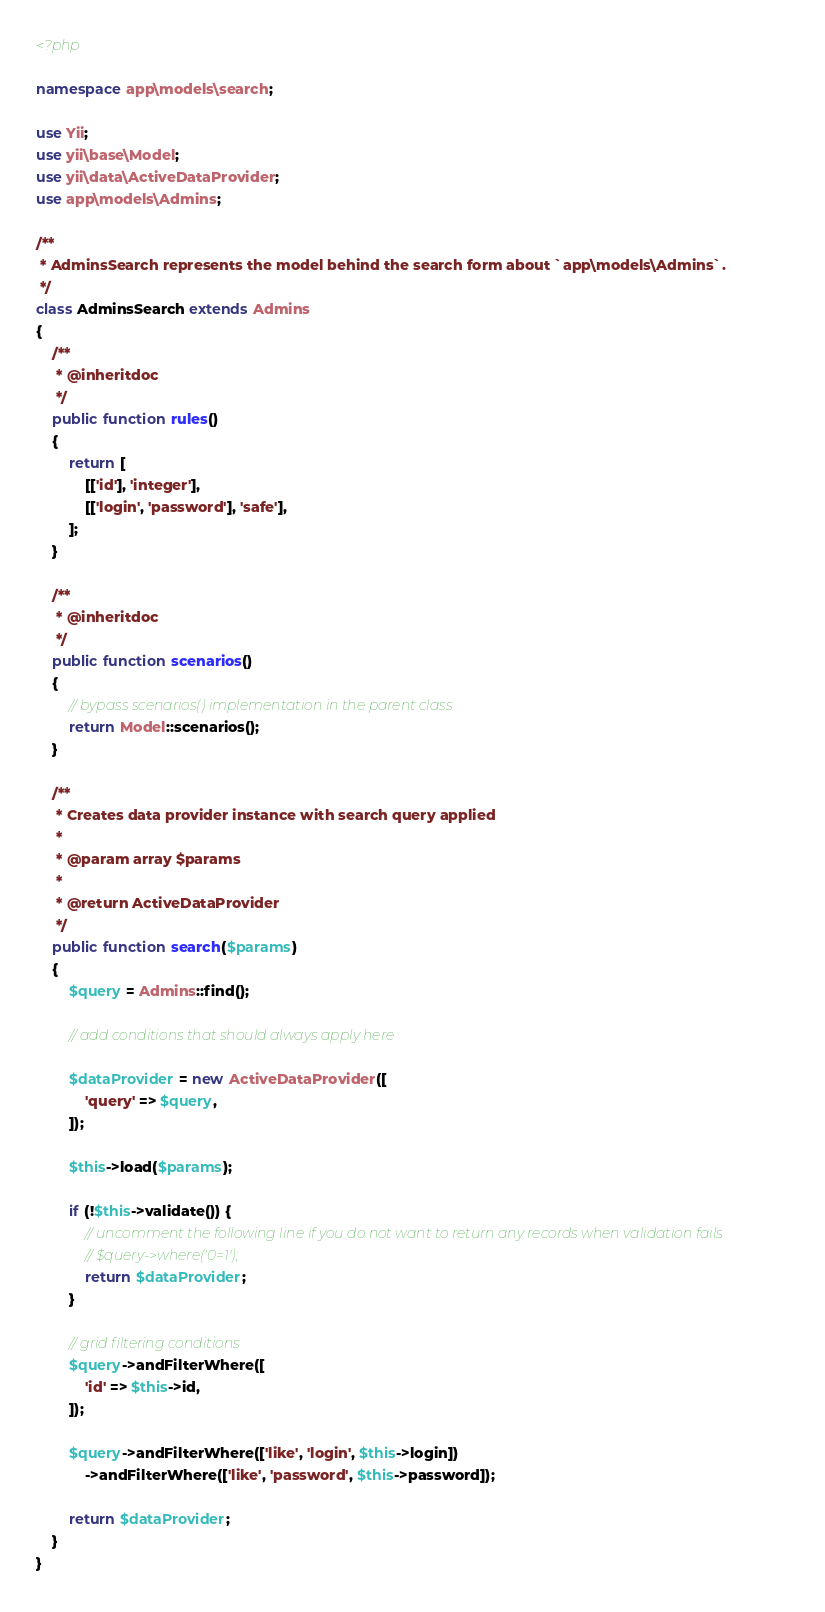<code> <loc_0><loc_0><loc_500><loc_500><_PHP_><?php

namespace app\models\search;

use Yii;
use yii\base\Model;
use yii\data\ActiveDataProvider;
use app\models\Admins;

/**
 * AdminsSearch represents the model behind the search form about `app\models\Admins`.
 */
class AdminsSearch extends Admins
{
    /**
     * @inheritdoc
     */
    public function rules()
    {
        return [
            [['id'], 'integer'],
            [['login', 'password'], 'safe'],
        ];
    }

    /**
     * @inheritdoc
     */
    public function scenarios()
    {
        // bypass scenarios() implementation in the parent class
        return Model::scenarios();
    }

    /**
     * Creates data provider instance with search query applied
     *
     * @param array $params
     *
     * @return ActiveDataProvider
     */
    public function search($params)
    {
        $query = Admins::find();

        // add conditions that should always apply here

        $dataProvider = new ActiveDataProvider([
            'query' => $query,
        ]);

        $this->load($params);

        if (!$this->validate()) {
            // uncomment the following line if you do not want to return any records when validation fails
            // $query->where('0=1');
            return $dataProvider;
        }

        // grid filtering conditions
        $query->andFilterWhere([
            'id' => $this->id,
        ]);

        $query->andFilterWhere(['like', 'login', $this->login])
            ->andFilterWhere(['like', 'password', $this->password]);

        return $dataProvider;
    }
}
</code> 